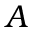<formula> <loc_0><loc_0><loc_500><loc_500>A</formula> 